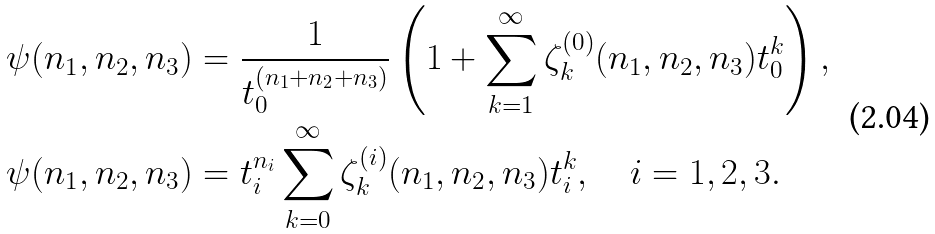<formula> <loc_0><loc_0><loc_500><loc_500>\psi ( n _ { 1 } , n _ { 2 } , n _ { 3 } ) & = \frac { 1 } { t _ { 0 } ^ { ( n _ { 1 } + n _ { 2 } + n _ { 3 } ) } } \left ( 1 + \sum _ { k = 1 } ^ { \infty } \zeta ^ { ( 0 ) } _ { k } ( n _ { 1 } , n _ { 2 } , n _ { 3 } ) t _ { 0 } ^ { k } \right ) , \\ \psi ( n _ { 1 } , n _ { 2 } , n _ { 3 } ) & = t _ { i } ^ { n _ { i } } \sum _ { k = 0 } ^ { \infty } \zeta ^ { ( i ) } _ { k } ( n _ { 1 } , n _ { 2 } , n _ { 3 } ) t _ { i } ^ { k } , \quad i = 1 , 2 , 3 .</formula> 